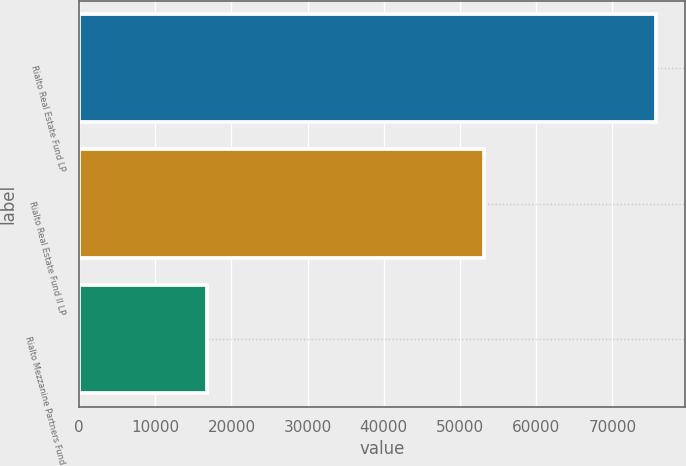Convert chart to OTSL. <chart><loc_0><loc_0><loc_500><loc_500><bar_chart><fcel>Rialto Real Estate Fund LP<fcel>Rialto Real Estate Fund II LP<fcel>Rialto Mezzanine Partners Fund<nl><fcel>75729<fcel>53103<fcel>16724<nl></chart> 